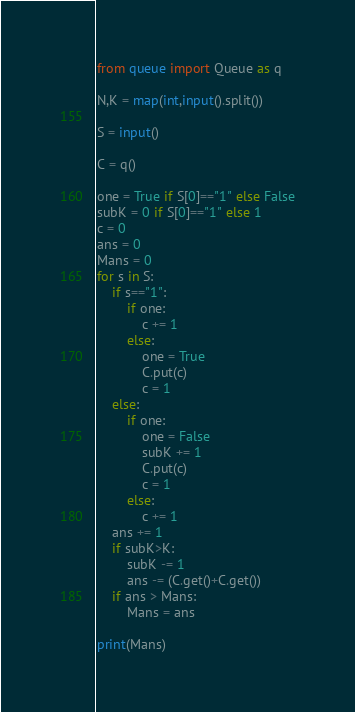<code> <loc_0><loc_0><loc_500><loc_500><_Python_>from queue import Queue as q

N,K = map(int,input().split())

S = input()

C = q()

one = True if S[0]=="1" else False
subK = 0 if S[0]=="1" else 1
c = 0
ans = 0
Mans = 0
for s in S:
    if s=="1":
        if one:
            c += 1
        else:
            one = True
            C.put(c)
            c = 1
    else:
        if one:
            one = False
            subK += 1
            C.put(c)
            c = 1
        else:
            c += 1
    ans += 1
    if subK>K:
        subK -= 1
        ans -= (C.get()+C.get())
    if ans > Mans:
        Mans = ans
    
print(Mans)</code> 